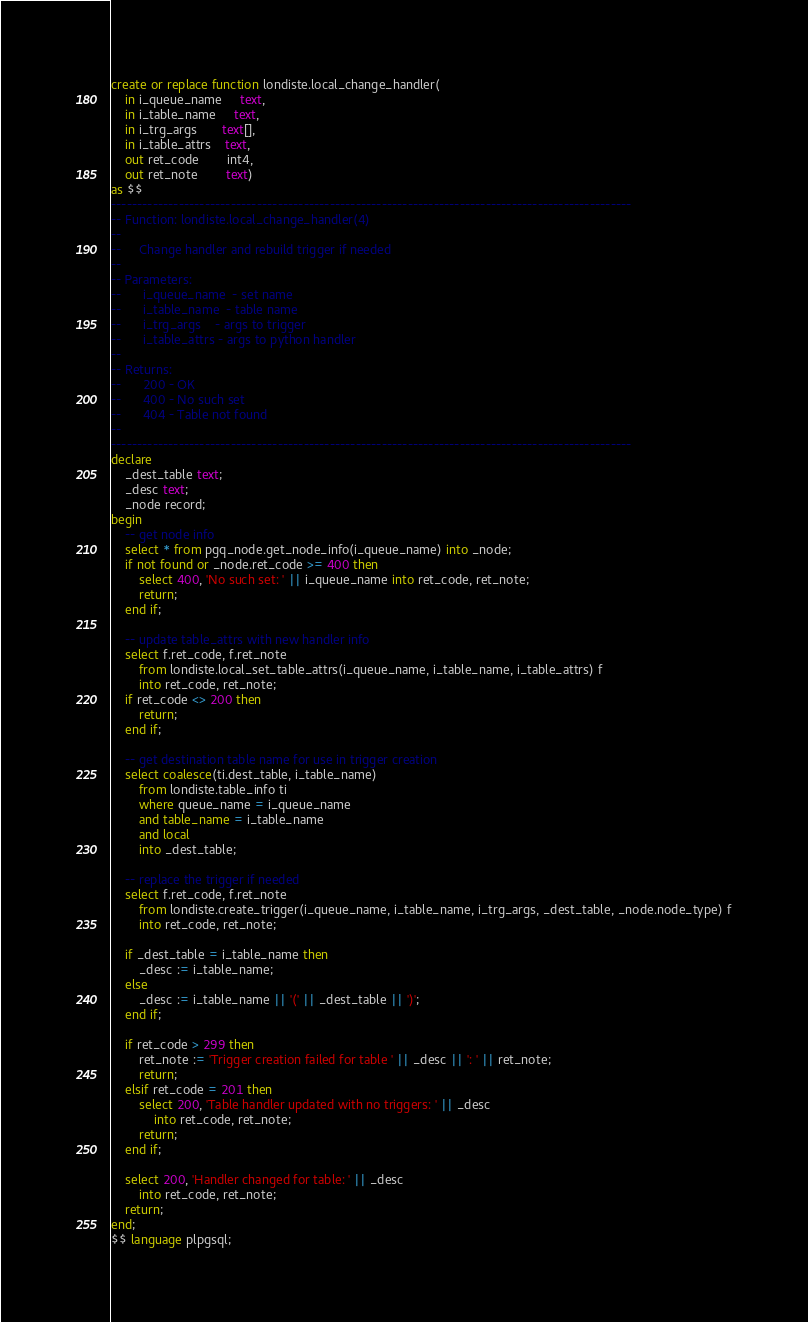<code> <loc_0><loc_0><loc_500><loc_500><_SQL_>create or replace function londiste.local_change_handler(
    in i_queue_name     text,
    in i_table_name     text,
    in i_trg_args       text[],
    in i_table_attrs    text,
    out ret_code        int4,
    out ret_note        text)
as $$
----------------------------------------------------------------------------------------------------
-- Function: londiste.local_change_handler(4)
--
--     Change handler and rebuild trigger if needed
--
-- Parameters:
--      i_queue_name  - set name
--      i_table_name  - table name
--      i_trg_args    - args to trigger
--      i_table_attrs - args to python handler
--
-- Returns:
--      200 - OK
--      400 - No such set
--      404 - Table not found
--
----------------------------------------------------------------------------------------------------
declare
    _dest_table text;
    _desc text;
    _node record;
begin
    -- get node info
    select * from pgq_node.get_node_info(i_queue_name) into _node;
    if not found or _node.ret_code >= 400 then
        select 400, 'No such set: ' || i_queue_name into ret_code, ret_note;
        return;
    end if;

    -- update table_attrs with new handler info
    select f.ret_code, f.ret_note
        from londiste.local_set_table_attrs(i_queue_name, i_table_name, i_table_attrs) f
        into ret_code, ret_note;
    if ret_code <> 200 then
        return;
    end if;

    -- get destination table name for use in trigger creation
    select coalesce(ti.dest_table, i_table_name)
        from londiste.table_info ti
        where queue_name = i_queue_name
        and table_name = i_table_name
        and local
        into _dest_table;

    -- replace the trigger if needed
    select f.ret_code, f.ret_note
        from londiste.create_trigger(i_queue_name, i_table_name, i_trg_args, _dest_table, _node.node_type) f
        into ret_code, ret_note;

    if _dest_table = i_table_name then
        _desc := i_table_name;
    else
        _desc := i_table_name || '(' || _dest_table || ')';
    end if;

    if ret_code > 299 then
        ret_note := 'Trigger creation failed for table ' || _desc || ': ' || ret_note;
        return;
    elsif ret_code = 201 then
        select 200, 'Table handler updated with no triggers: ' || _desc
            into ret_code, ret_note;
        return;
    end if;

    select 200, 'Handler changed for table: ' || _desc
        into ret_code, ret_note;
    return;
end;
$$ language plpgsql;
</code> 